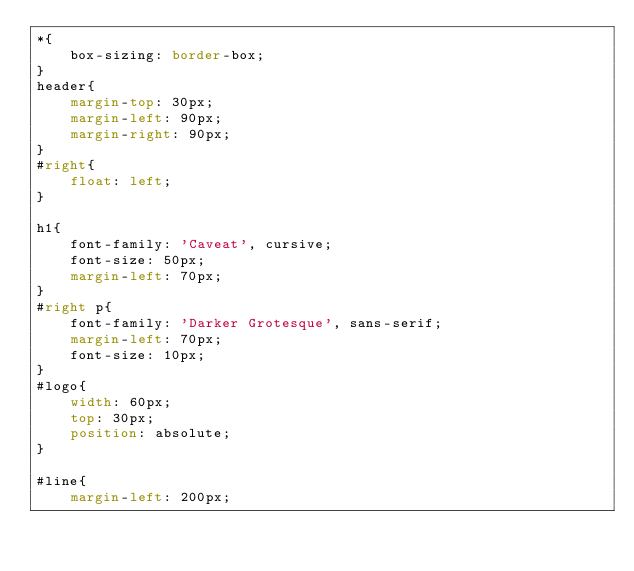<code> <loc_0><loc_0><loc_500><loc_500><_CSS_>*{
    box-sizing: border-box;
}
header{
    margin-top: 30px;
    margin-left: 90px;
    margin-right: 90px;
}
#right{
    float: left;
}

h1{
    font-family: 'Caveat', cursive;
    font-size: 50px;
    margin-left: 70px;
}
#right p{
    font-family: 'Darker Grotesque', sans-serif;
    margin-left: 70px;
    font-size: 10px;
}
#logo{
    width: 60px;
    top: 30px;
    position: absolute;
}

#line{
    margin-left: 200px;</code> 